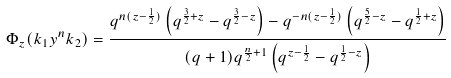<formula> <loc_0><loc_0><loc_500><loc_500>\Phi _ { z } ( k _ { 1 } y ^ { n } k _ { 2 } ) = \frac { q ^ { n ( z - \frac { 1 } { 2 } ) } \left ( q ^ { \frac { 3 } { 2 } + z } - q ^ { \frac { 3 } { 2 } - z } \right ) - q ^ { - n ( z - \frac { 1 } { 2 } ) } \left ( q ^ { \frac { 5 } { 2 } - z } - q ^ { \frac { 1 } { 2 } + z } \right ) } { ( q + 1 ) q ^ { \frac { n } { 2 } + 1 } \left ( q ^ { z - \frac { 1 } { 2 } } - q ^ { \frac { 1 } { 2 } - z } \right ) }</formula> 